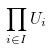Convert formula to latex. <formula><loc_0><loc_0><loc_500><loc_500>\prod _ { i \in I } U _ { i }</formula> 